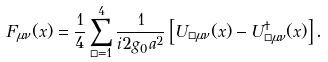<formula> <loc_0><loc_0><loc_500><loc_500>F _ { \mu \nu } ( x ) = \frac { 1 } { 4 } \sum _ { \Box = 1 } ^ { 4 } \frac { 1 } { i 2 g _ { 0 } a ^ { 2 } } \left [ U _ { \Box \mu \nu } ( x ) - U _ { \Box \mu \nu } ^ { \dagger } ( x ) \right ] .</formula> 